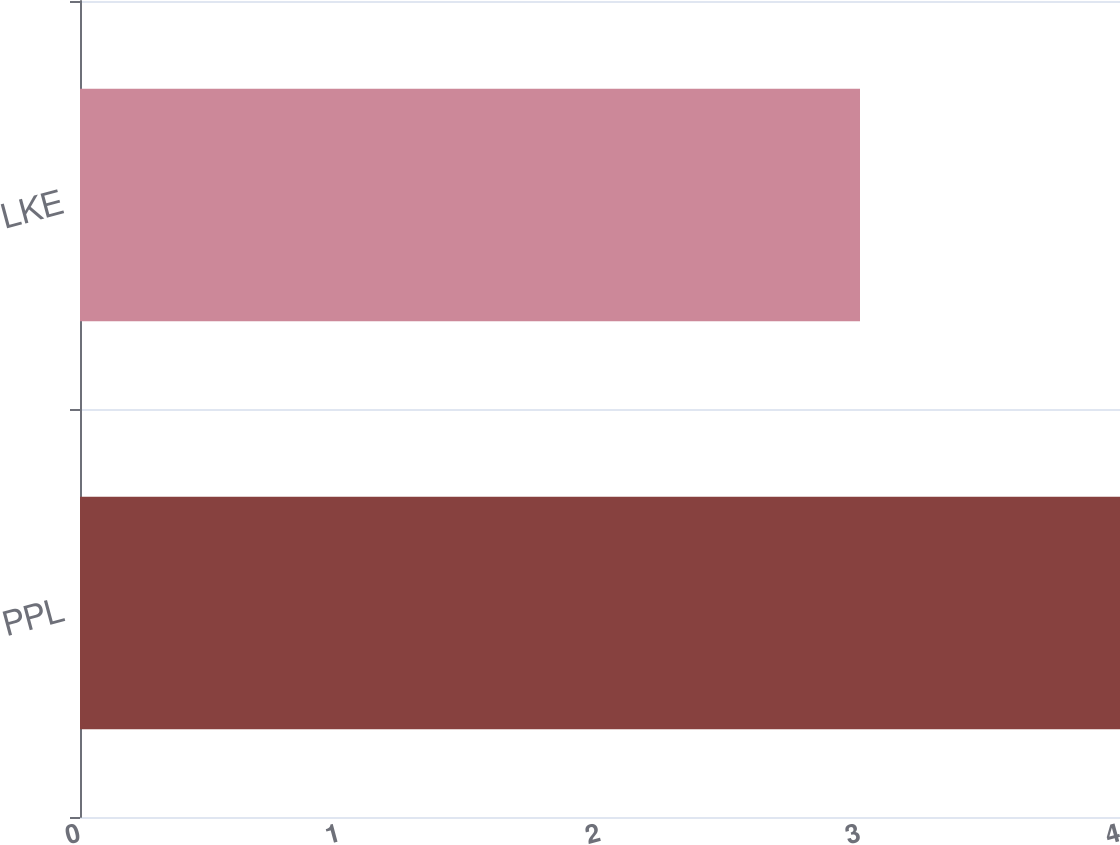Convert chart to OTSL. <chart><loc_0><loc_0><loc_500><loc_500><bar_chart><fcel>PPL<fcel>LKE<nl><fcel>4<fcel>3<nl></chart> 